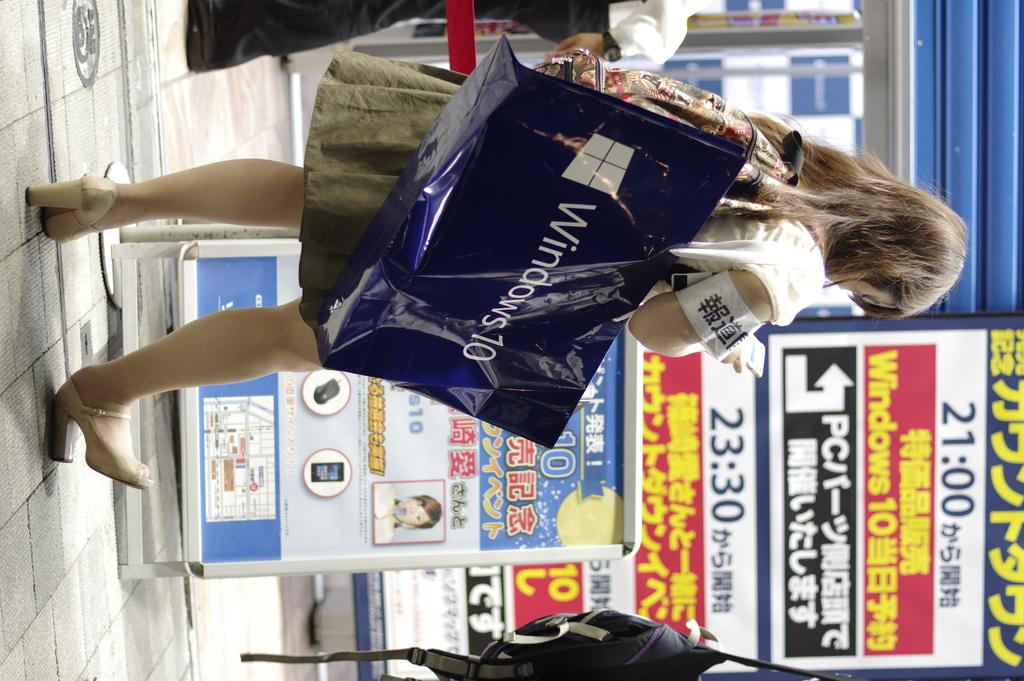<image>
Give a short and clear explanation of the subsequent image. A women carrying a Windows 10 bag walks toward a store with foreign writing on the window. 